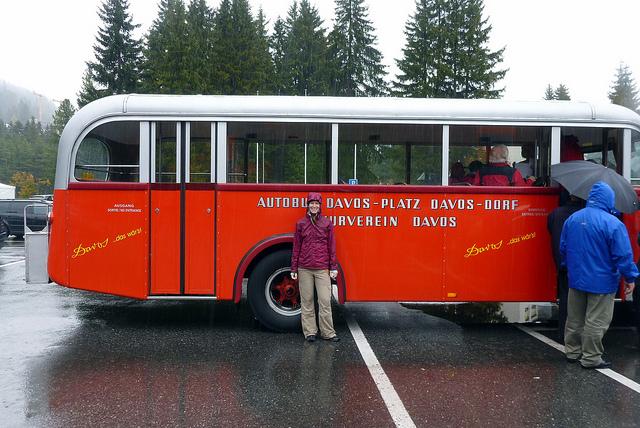What color is the bus?
Keep it brief. Red and white. Is it raining?
Answer briefly. Yes. Is this bus parked right now?
Short answer required. Yes. 